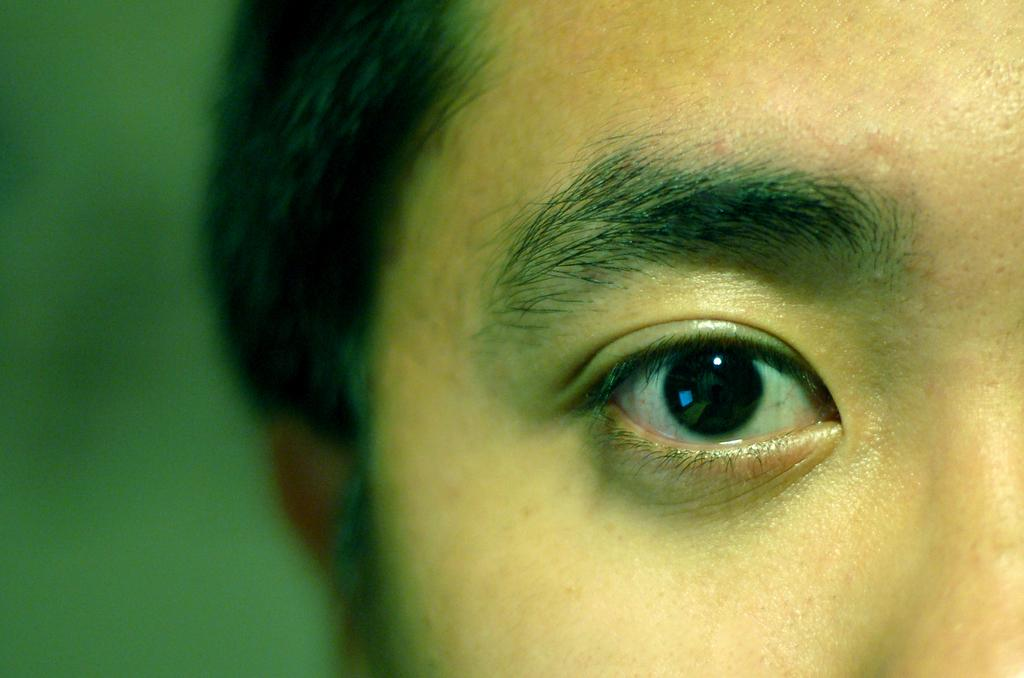What is the main subject of the picture? The main subject of the picture is the partial face of a person. What color is present on the left side of the image? The left side of the image has green color. What type of quilt is being used for learning in the image? There is no quilt or learning activity depicted in the image; it features a partial face of a person and green color on the left side. 